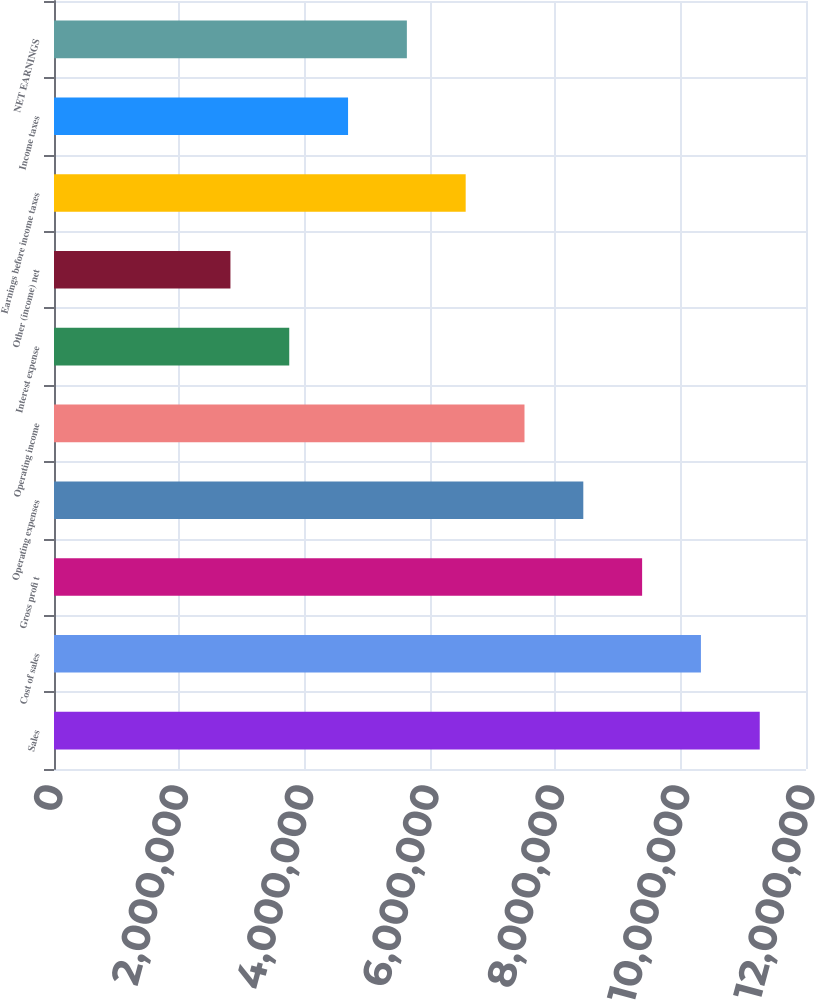Convert chart. <chart><loc_0><loc_0><loc_500><loc_500><bar_chart><fcel>Sales<fcel>Cost of sales<fcel>Gross profi t<fcel>Operating expenses<fcel>Operating income<fcel>Interest expense<fcel>Other (income) net<fcel>Earnings before income taxes<fcel>Income taxes<fcel>NET EARNINGS<nl><fcel>1.12618e+07<fcel>1.03233e+07<fcel>9.38485e+06<fcel>8.44637e+06<fcel>7.50788e+06<fcel>3.75394e+06<fcel>2.81546e+06<fcel>6.5694e+06<fcel>4.69243e+06<fcel>5.63091e+06<nl></chart> 